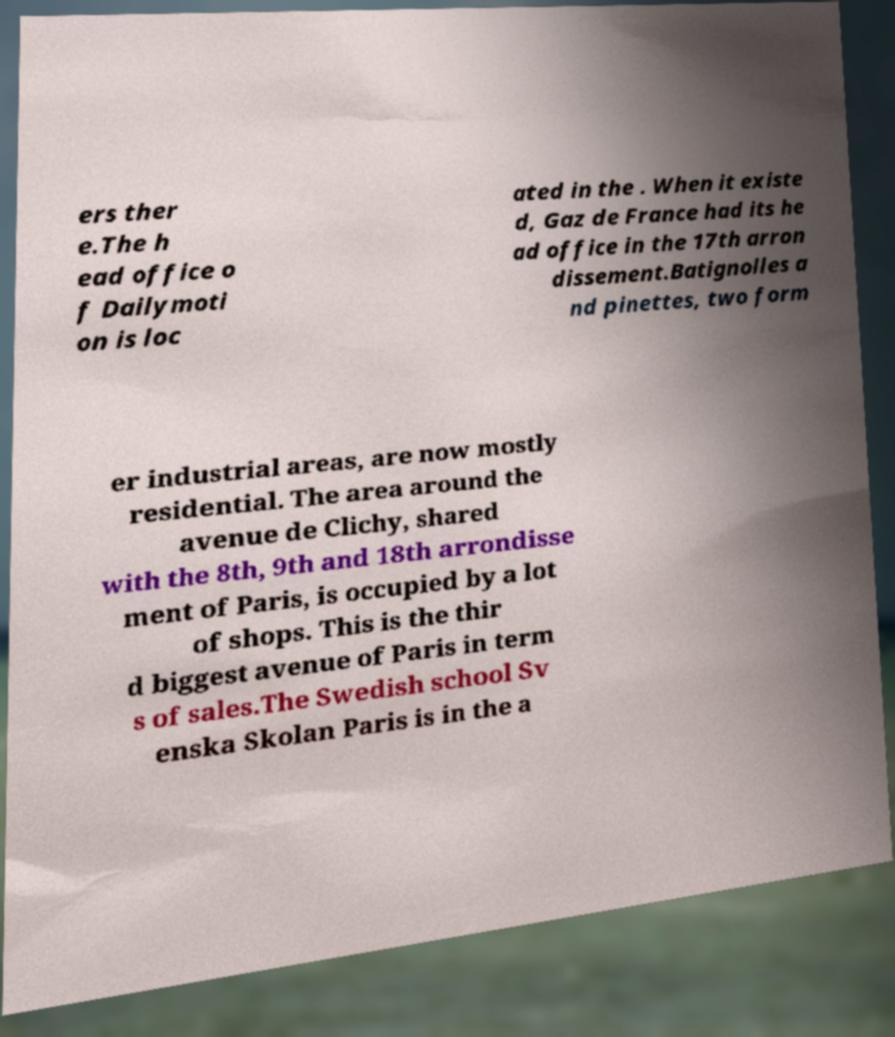Can you read and provide the text displayed in the image?This photo seems to have some interesting text. Can you extract and type it out for me? ers ther e.The h ead office o f Dailymoti on is loc ated in the . When it existe d, Gaz de France had its he ad office in the 17th arron dissement.Batignolles a nd pinettes, two form er industrial areas, are now mostly residential. The area around the avenue de Clichy, shared with the 8th, 9th and 18th arrondisse ment of Paris, is occupied by a lot of shops. This is the thir d biggest avenue of Paris in term s of sales.The Swedish school Sv enska Skolan Paris is in the a 